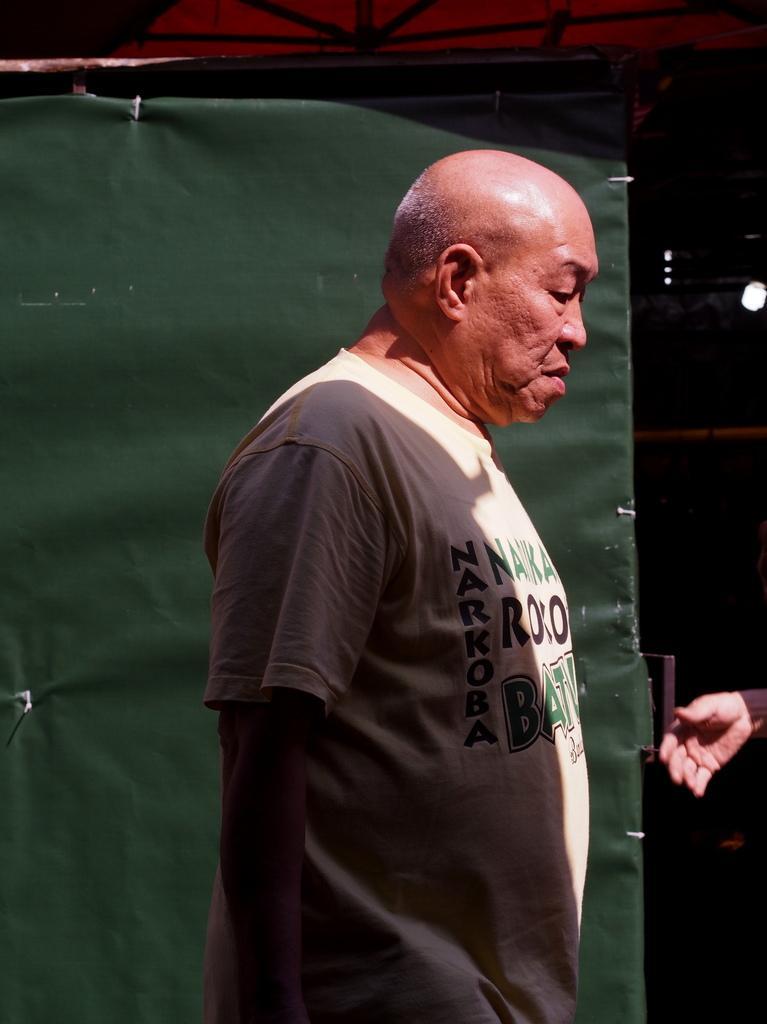Please provide a concise description of this image. In this image we can see a person standing, also we can see a green color object and a person's hand, the background is dark. 